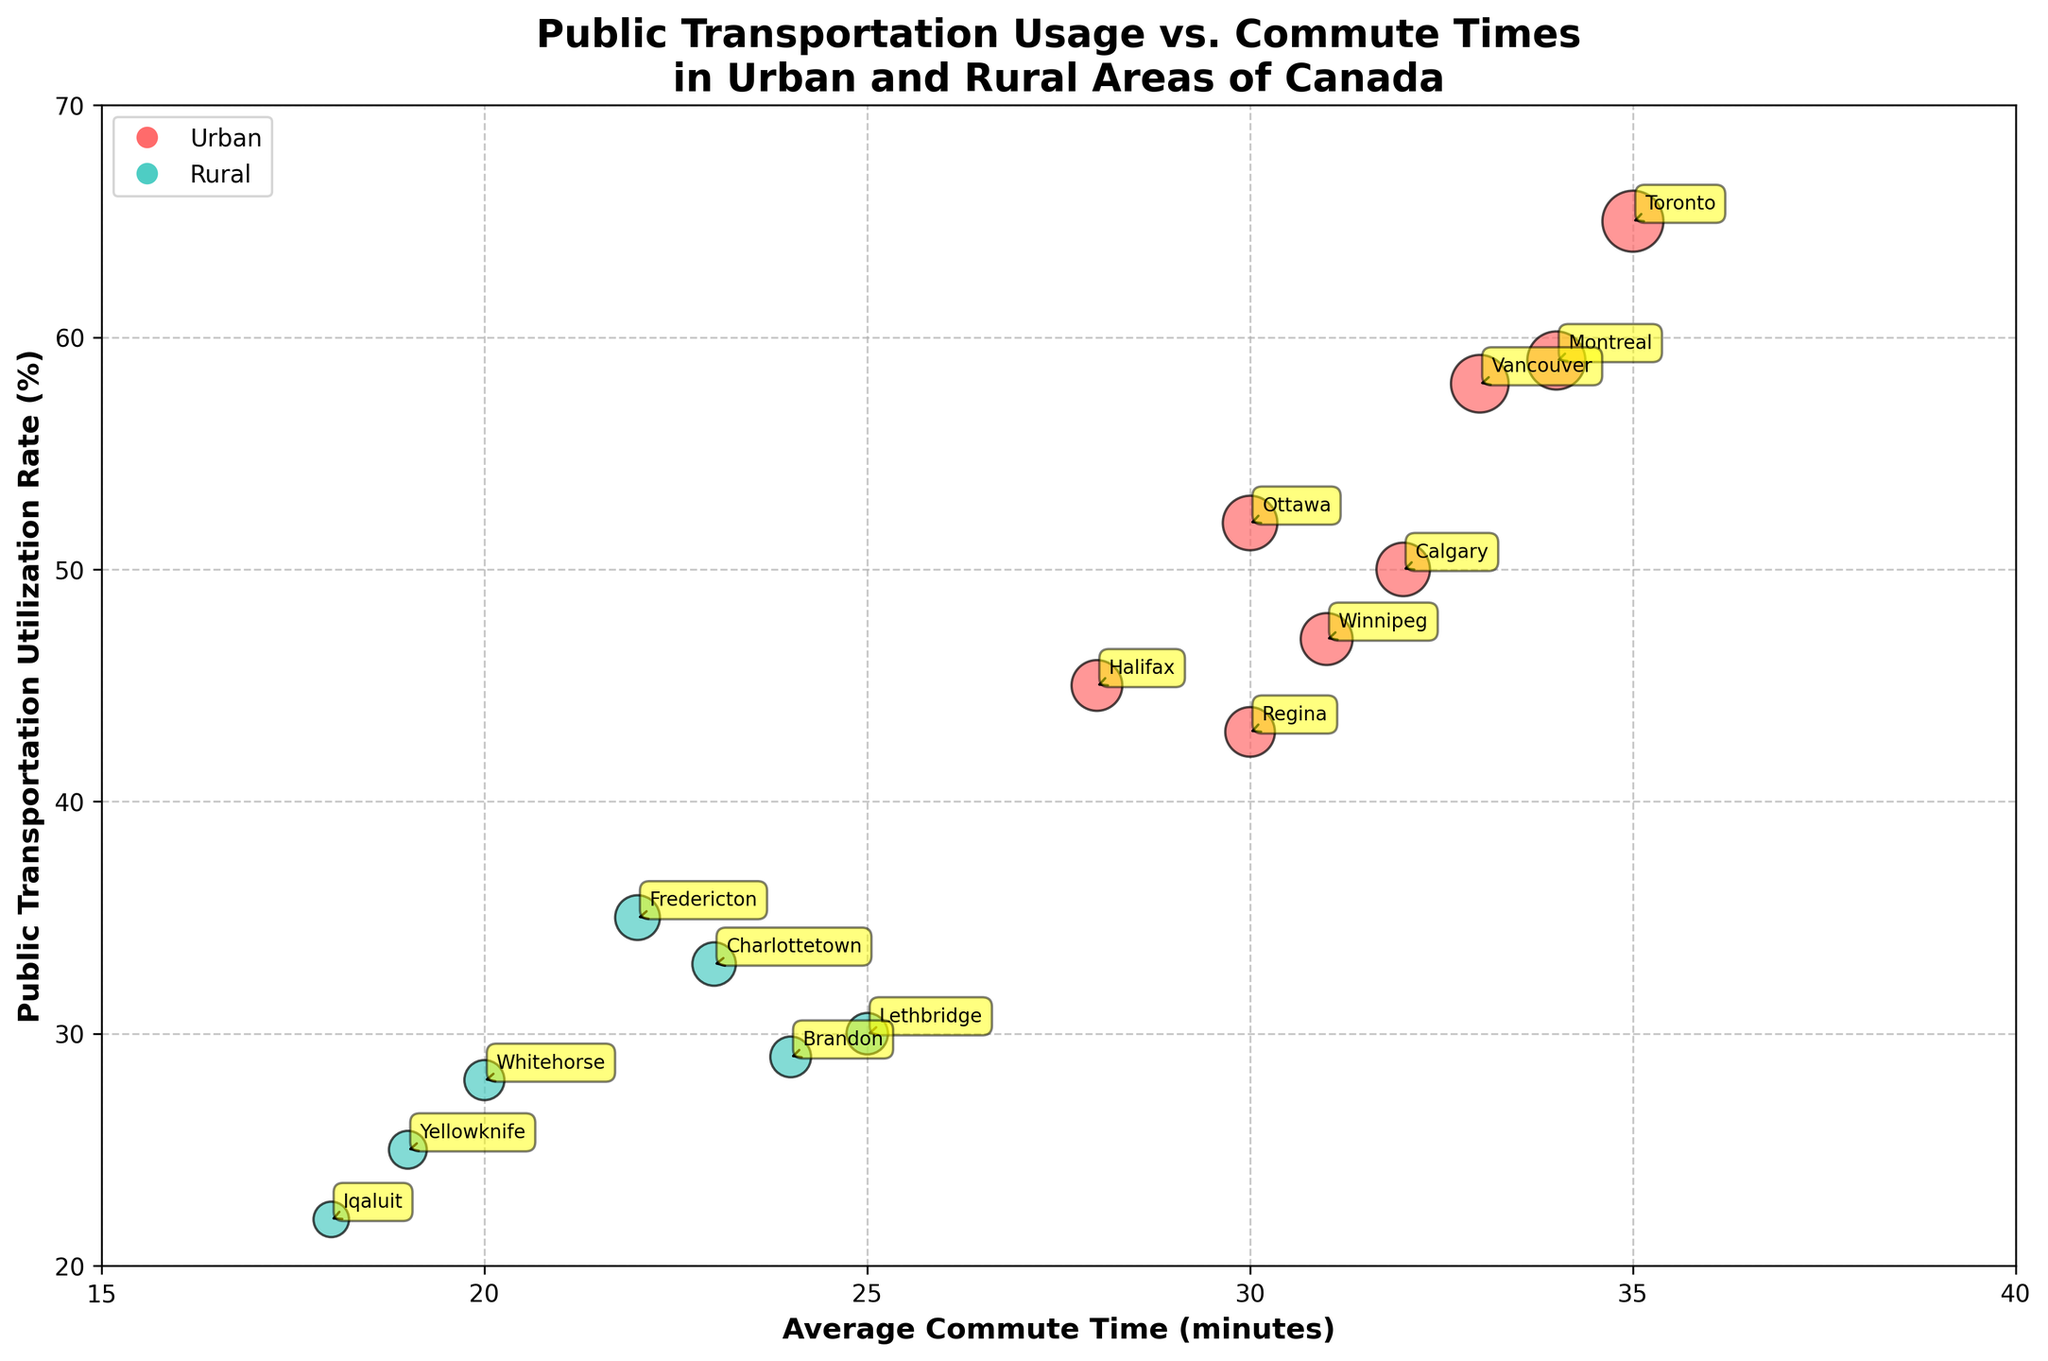What's the title of the figure? The title of the figure is clearly labeled at the top.
Answer: Public Transportation Usage vs. Commute Times in Urban and Rural Areas of Canada What's the y-axis label? The y-axis label is written along the y-axis.
Answer: Public Transportation Utilization Rate (%) How many urban areas are included in the plot? To determine this, you need to count the number of data points labeled with city names that are classified as urban.
Answer: 8 How many rural areas are included in the plot? To determine this, you need to count the number of data points labeled with city names that are classified as rural.
Answer: 7 Which area has the shortest average commute time? Find the area with the lowest value on the x-axis.
Answer: Iqaluit Which area has the highest public transportation utilization rate? Find the area with the highest value on the y-axis.
Answer: Toronto Do urban or rural areas generally have higher public transportation utilization rates? Observe the y-axis positions of urban (red) vs rural (green) data points.
Answer: Urban areas What is the average public transportation utilization rate for rural areas? Sum the y-values of all rural areas and divide by the number of rural entries: (35 + 33 + 30 + 28 + 25 + 22 + 29)/7.
Answer: ~28 What is the difference in average commute time between urban and rural areas? Calculate the average x-values for both urban and rural areas, then find the difference: Urban average = (35+34+33+32+30+28+31+30)/8 = 31.63, Rural average = (22+23+25+20+19+18+24)/7 = 21.57. The difference is 31.63 - 21.57.
Answer: ~10 minutes Do any rural areas have a public transportation utilization rate above 35%? Check the y-values for rural data points to see if any exceeds 35%.
Answer: No 